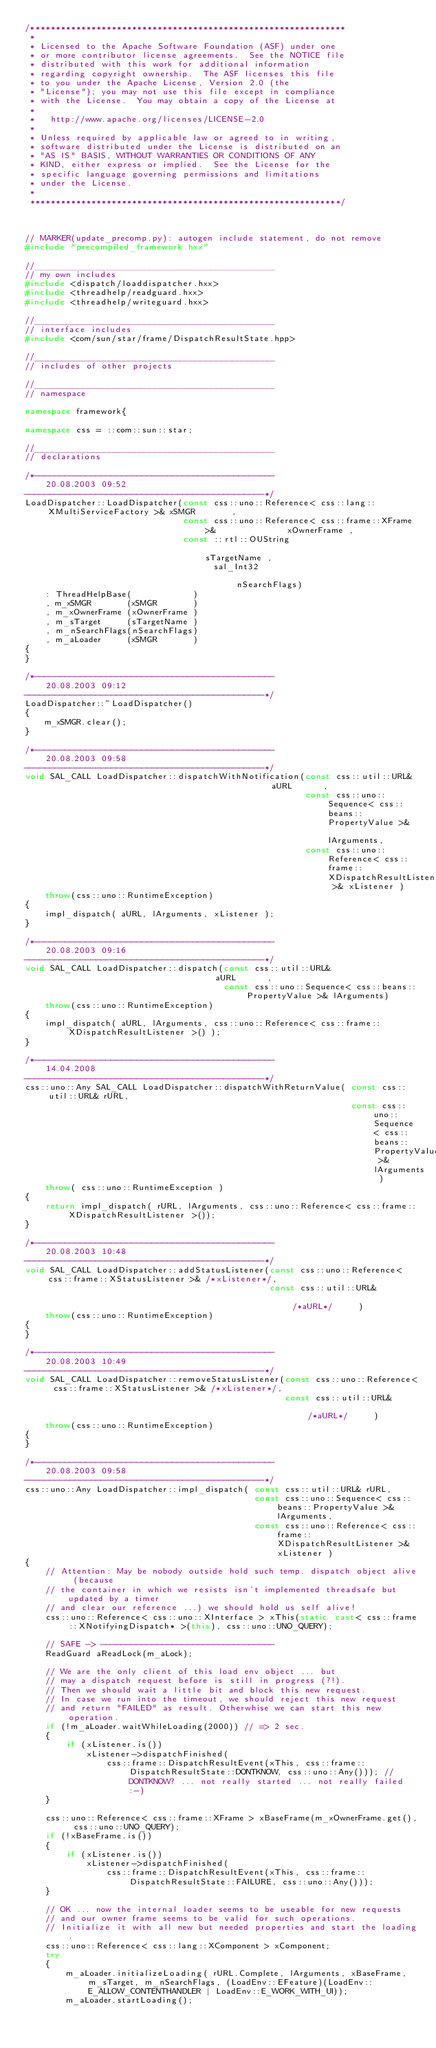Convert code to text. <code><loc_0><loc_0><loc_500><loc_500><_C++_>/**************************************************************
 * 
 * Licensed to the Apache Software Foundation (ASF) under one
 * or more contributor license agreements.  See the NOTICE file
 * distributed with this work for additional information
 * regarding copyright ownership.  The ASF licenses this file
 * to you under the Apache License, Version 2.0 (the
 * "License"); you may not use this file except in compliance
 * with the License.  You may obtain a copy of the License at
 * 
 *   http://www.apache.org/licenses/LICENSE-2.0
 * 
 * Unless required by applicable law or agreed to in writing,
 * software distributed under the License is distributed on an
 * "AS IS" BASIS, WITHOUT WARRANTIES OR CONDITIONS OF ANY
 * KIND, either express or implied.  See the License for the
 * specific language governing permissions and limitations
 * under the License.
 * 
 *************************************************************/



// MARKER(update_precomp.py): autogen include statement, do not remove
#include "precompiled_framework.hxx"

//_______________________________________________
// my own includes
#include <dispatch/loaddispatcher.hxx>
#include <threadhelp/readguard.hxx>
#include <threadhelp/writeguard.hxx>

//_______________________________________________
// interface includes
#include <com/sun/star/frame/DispatchResultState.hpp>

//_______________________________________________
// includes of other projects

//_______________________________________________
// namespace

namespace framework{

namespace css = ::com::sun::star;

//_______________________________________________
// declarations

/*-----------------------------------------------
    20.08.2003 09:52
-----------------------------------------------*/
LoadDispatcher::LoadDispatcher(const css::uno::Reference< css::lang::XMultiServiceFactory >& xSMGR       ,
                               const css::uno::Reference< css::frame::XFrame >&              xOwnerFrame ,
                               const ::rtl::OUString                                         sTargetName ,
                                     sal_Int32                                               nSearchFlags)
    : ThreadHelpBase(            )
    , m_xSMGR       (xSMGR       )
    , m_xOwnerFrame (xOwnerFrame )
    , m_sTarget     (sTargetName )
    , m_nSearchFlags(nSearchFlags)
    , m_aLoader     (xSMGR       )
{
}

/*-----------------------------------------------
    20.08.2003 09:12
-----------------------------------------------*/
LoadDispatcher::~LoadDispatcher()
{
    m_xSMGR.clear();
}

/*-----------------------------------------------
    20.08.2003 09:58
-----------------------------------------------*/
void SAL_CALL LoadDispatcher::dispatchWithNotification(const css::util::URL&                                             aURL      ,
                                                       const css::uno::Sequence< css::beans::PropertyValue >&            lArguments,
                                                       const css::uno::Reference< css::frame::XDispatchResultListener >& xListener )
    throw(css::uno::RuntimeException)
{
    impl_dispatch( aURL, lArguments, xListener );
}

/*-----------------------------------------------
    20.08.2003 09:16
-----------------------------------------------*/
void SAL_CALL LoadDispatcher::dispatch(const css::util::URL&                                  aURL      ,
                                       const css::uno::Sequence< css::beans::PropertyValue >& lArguments)
    throw(css::uno::RuntimeException)
{
    impl_dispatch( aURL, lArguments, css::uno::Reference< css::frame::XDispatchResultListener >() );
}

/*-----------------------------------------------
    14.04.2008
-----------------------------------------------*/
css::uno::Any SAL_CALL LoadDispatcher::dispatchWithReturnValue( const css::util::URL& rURL,
                                                                const css::uno::Sequence< css::beans::PropertyValue >& lArguments )
    throw( css::uno::RuntimeException )
{
    return impl_dispatch( rURL, lArguments, css::uno::Reference< css::frame::XDispatchResultListener >());
}

/*-----------------------------------------------
    20.08.2003 10:48
-----------------------------------------------*/
void SAL_CALL LoadDispatcher::addStatusListener(const css::uno::Reference< css::frame::XStatusListener >& /*xListener*/,
                                                const css::util::URL&                                     /*aURL*/     )
    throw(css::uno::RuntimeException)
{
}

/*-----------------------------------------------
    20.08.2003 10:49
-----------------------------------------------*/
void SAL_CALL LoadDispatcher::removeStatusListener(const css::uno::Reference< css::frame::XStatusListener >& /*xListener*/,
                                                   const css::util::URL&                                     /*aURL*/     )
    throw(css::uno::RuntimeException)
{
}

/*-----------------------------------------------
    20.08.2003 09:58
-----------------------------------------------*/
css::uno::Any LoadDispatcher::impl_dispatch( const css::util::URL& rURL,
                                             const css::uno::Sequence< css::beans::PropertyValue >& lArguments,
                                             const css::uno::Reference< css::frame::XDispatchResultListener >& xListener )
{
    // Attention: May be nobody outside hold such temp. dispatch object alive (because
    // the container in which we resists isn't implemented threadsafe but updated by a timer
    // and clear our reference ...) we should hold us self alive!
    css::uno::Reference< css::uno::XInterface > xThis(static_cast< css::frame::XNotifyingDispatch* >(this), css::uno::UNO_QUERY);

    // SAFE -> ----------------------------------
    ReadGuard aReadLock(m_aLock);

    // We are the only client of this load env object ... but
    // may a dispatch request before is still in progress (?!).
    // Then we should wait a little bit and block this new request.
    // In case we run into the timeout, we should reject this new request
    // and return "FAILED" as result. Otherwhise we can start this new operation.
    if (!m_aLoader.waitWhileLoading(2000)) // => 2 sec.
    {
        if (xListener.is())
            xListener->dispatchFinished(
                css::frame::DispatchResultEvent(xThis, css::frame::DispatchResultState::DONTKNOW, css::uno::Any())); // DONTKNOW? ... not really started ... not really failed :-)
    }

    css::uno::Reference< css::frame::XFrame > xBaseFrame(m_xOwnerFrame.get(), css::uno::UNO_QUERY);
    if (!xBaseFrame.is())
    {
        if (xListener.is())
            xListener->dispatchFinished(
                css::frame::DispatchResultEvent(xThis, css::frame::DispatchResultState::FAILURE, css::uno::Any()));
    }

    // OK ... now the internal loader seems to be useable for new requests
    // and our owner frame seems to be valid for such operations.
    // Initialize it with all new but needed properties and start the loading.
    css::uno::Reference< css::lang::XComponent > xComponent;
    try
    {
        m_aLoader.initializeLoading( rURL.Complete, lArguments, xBaseFrame, m_sTarget, m_nSearchFlags, (LoadEnv::EFeature)(LoadEnv::E_ALLOW_CONTENTHANDLER | LoadEnv::E_WORK_WITH_UI));
        m_aLoader.startLoading();</code> 